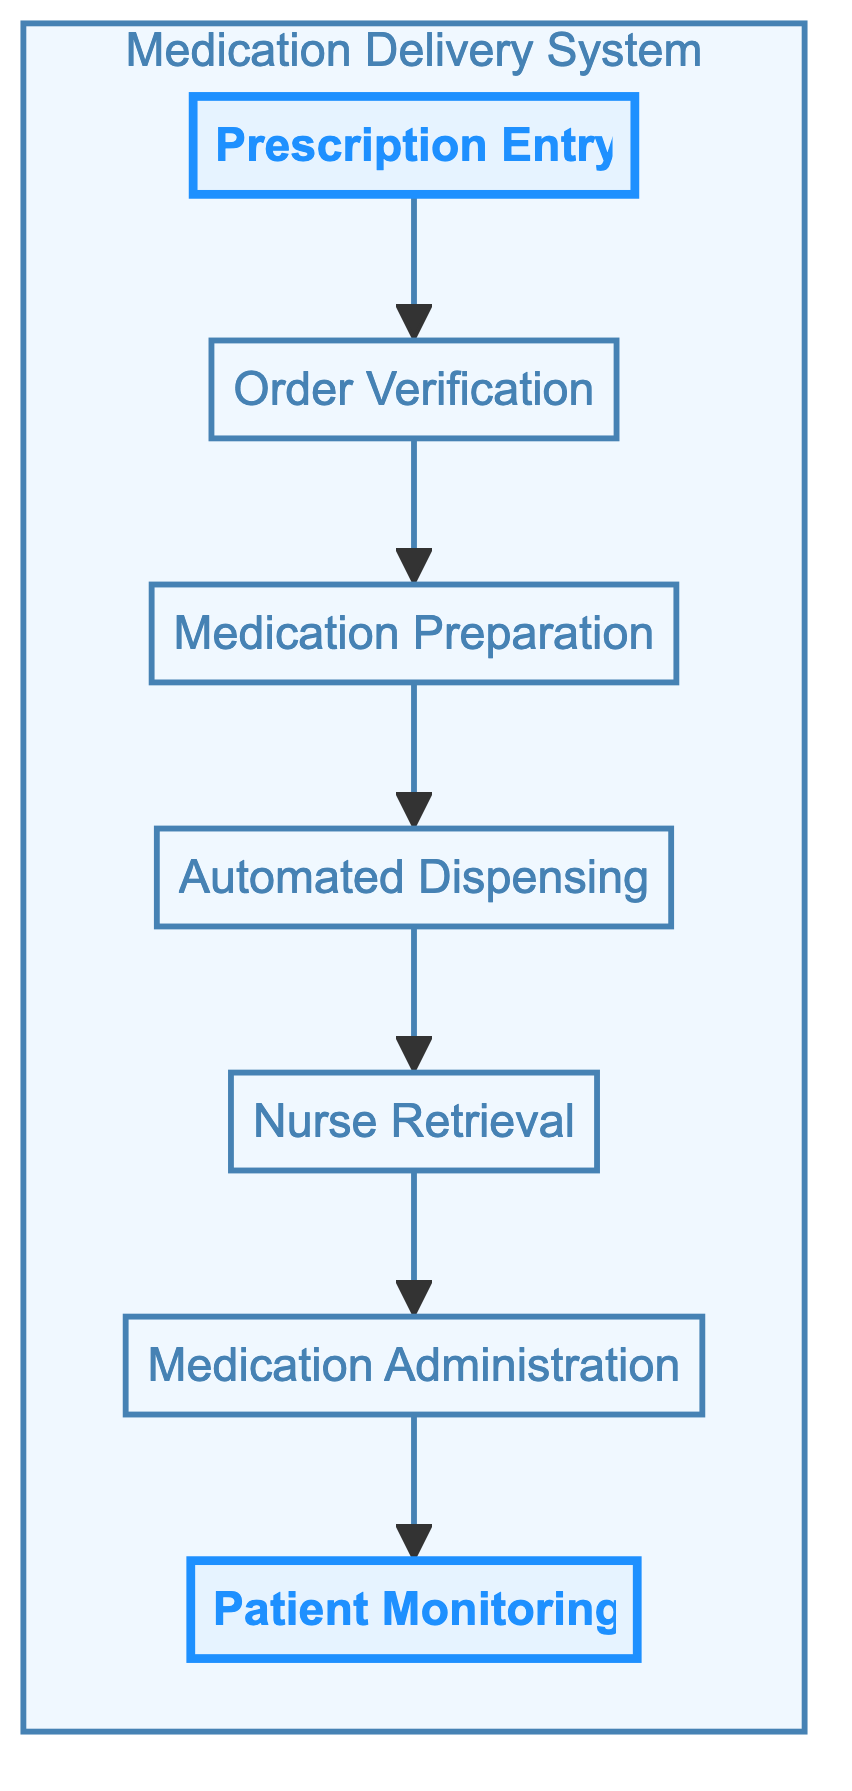What is the first step in the medication delivery system? The diagram starts with the "Prescription Entry" step, indicating it is the initial action in the flow.
Answer: Prescription Entry How many steps are there in total? By counting the nodes in the diagram, we have seven distinct steps, indicating all the major actions in the process.
Answer: Seven What step comes after "Medication Preparation"? The diagram shows that "Automated Dispensing" directly follows "Medication Preparation," indicating the sequential flow of steps.
Answer: Automated Dispensing Which step involves nurse action? "Nurse Retrieval" and "Medication Administration" are both steps that involve active participation by nurses, showing their integral role in the process.
Answer: Nurse Retrieval and Medication Administration What is documented during "Patient Monitoring"? The step "Patient Monitoring" is responsible for documenting findings in the electronic health record, emphasizing the need for continuous assessment.
Answer: Findings in the EHR Which step is highlighted in the diagram? The beginning ("Prescription Entry") and the end ("Patient Monitoring") steps are shaded differently in the diagram to indicate their significance.
Answer: Prescription Entry and Patient Monitoring What action happens between "Order Verification" and "Medication Preparation"? The "Medication Preparation" step directly follows "Order Verification," illustrating that these two actions are linked in the procedural flow.
Answer: None What type of system is being described by this flowchart? The flowchart outlines a "Medication Delivery System," which signifies the process from prescription to patient monitoring.
Answer: Medication Delivery System Which entity is responsible for preparing the medications? According to the diagram, "Pharmacy technicians" are specifically tasked with the preparation of medications, indicating a specialized role.
Answer: Pharmacy technicians 